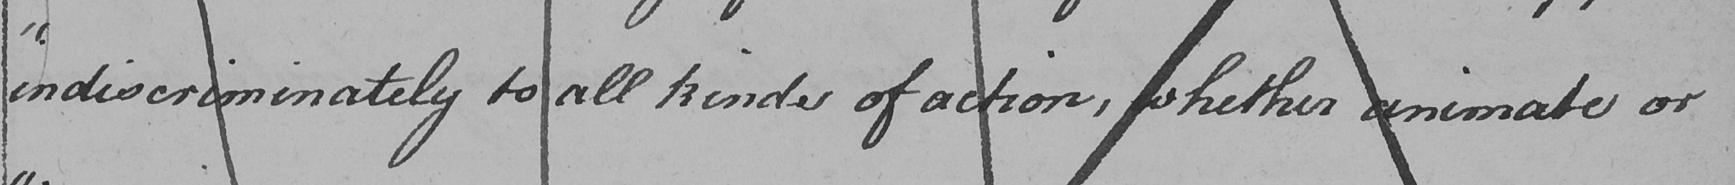Transcribe the text shown in this historical manuscript line. " indiscriminately to all kinds of action , whether animate or 